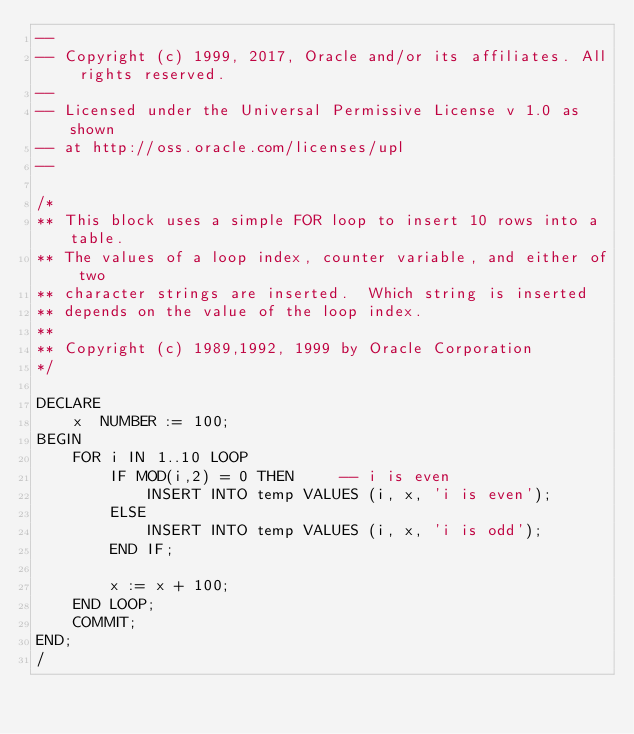Convert code to text. <code><loc_0><loc_0><loc_500><loc_500><_SQL_>--
-- Copyright (c) 1999, 2017, Oracle and/or its affiliates. All rights reserved.
--
-- Licensed under the Universal Permissive License v 1.0 as shown
-- at http://oss.oracle.com/licenses/upl
--

/*
** This block uses a simple FOR loop to insert 10 rows into a table.
** The values of a loop index, counter variable, and either of two
** character strings are inserted.  Which string is inserted
** depends on the value of the loop index.
**
** Copyright (c) 1989,1992, 1999 by Oracle Corporation
*/

DECLARE
    x  NUMBER := 100;
BEGIN
    FOR i IN 1..10 LOOP
        IF MOD(i,2) = 0 THEN     -- i is even
            INSERT INTO temp VALUES (i, x, 'i is even');
        ELSE
            INSERT INTO temp VALUES (i, x, 'i is odd');
        END IF;

        x := x + 100;
    END LOOP;
    COMMIT;
END;
/

</code> 